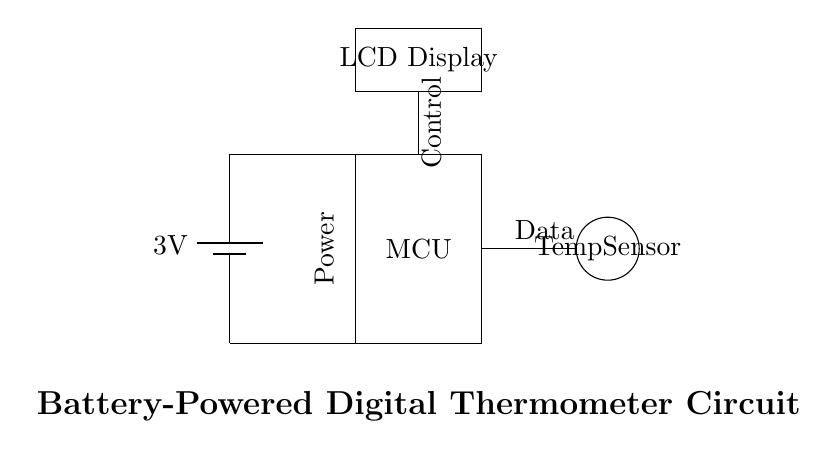What is the type of power source used in this circuit? The circuit uses a battery as the power source, indicated by the battery symbol at the start of the diagram. It is labeled with "3V", showing the voltage provided by the battery.
Answer: battery What does the acronym MCU stand for in the circuit? In the circuit, MCU stands for Microcontroller Unit, as labeled in the rectangle representing that component in the diagram. It serves as the control center for processing the temperature data.
Answer: Microcontroller Unit Which component is responsible for measuring temperature? The component that measures temperature is the temperature sensor, indicated by the circular shape labeled "Temp Sensor" in the circuit diagram.
Answer: Temp Sensor What voltage does the battery supply? The battery supplies a voltage of 3 volts, as specified directly next to the battery symbol in the circuit diagram.
Answer: 3 volts What type of display is used to show the temperature? The circuit uses an LCD display, as indicated in the rectangle labeled "LCD Display" positioned above the microcontroller in the diagram.
Answer: LCD display How does the temperature sensor connect to the Microcontroller? The temperature sensor is connected to the microcontroller via a data line, which can be inferred from the connection line extending towards the sensor from the MCU. This indicates that the microcontroller will receive temperature data from the sensor.
Answer: Data line What function does the control line in the circuit serve? The control line connecting the battery to the microcontroller controls the power supply to the MCU, ensuring it operates within the circuit's parameters. This line indicates that the MCU needs power to function and process data from the temperature sensor.
Answer: Power supply 